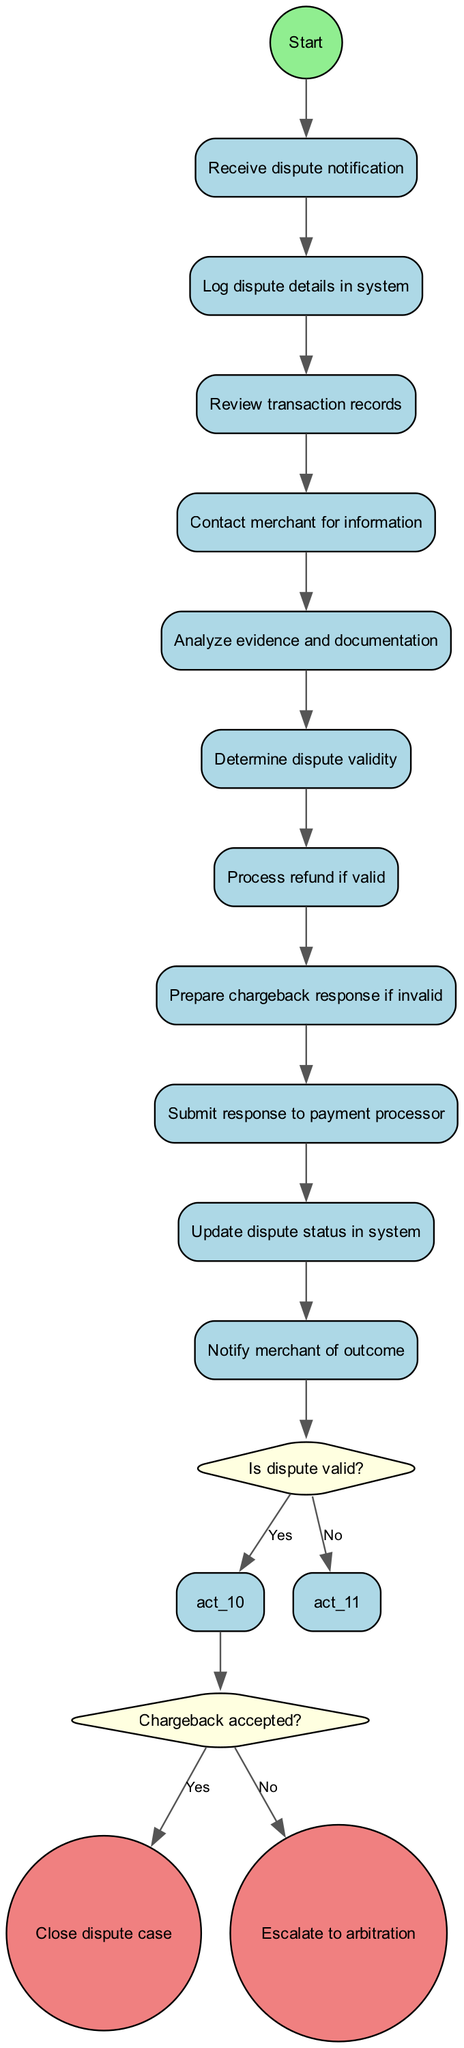What is the first activity in the process? The diagram starts with the "Receive dispute notification" node, indicating that this is the first activity that begins the process.
Answer: Receive dispute notification How many activities are there in the diagram? There are ten activities listed in the diagram, ranging from logging dispute details to notifying the merchant of the outcome.
Answer: 10 What decision is made after analyzing evidence? The decision made after analyzing evidence is "Is dispute valid?", which determines the next steps based on the validity of the dispute.
Answer: Is dispute valid? What happens if the dispute is not valid? If the dispute is not valid, the process leads to preparing a chargeback response, which is the next activity after determining the dispute's validity.
Answer: Prepare chargeback response How many outcomes are there after processing the decision of whether a chargeback is accepted? There are two outcomes after processing the decision: "Close dispute case" if accepted, or "Escalate to arbitration" if not accepted.
Answer: 2 What is the final activity before closing the dispute case? The final activity before closing the dispute case is to notify the merchant of the outcome, which must happen before the dispute is officially closed.
Answer: Notify merchant of outcome Which activity follows the "Review transaction records"? The activity that follows "Review transaction records" is "Contact merchant for information," as indicated by the order of tasks in the diagram.
Answer: Contact merchant for information What shape represents decisions in the diagram? Decisions in the diagram are represented by diamonds, indicating places where branches in the flow occur based on yes/no questions.
Answer: Diamond What action is taken if the dispute is determined to be valid? If the dispute is determined to be valid, the action taken is to process a refund to the customer as part of resolving the dispute.
Answer: Process refund if valid 